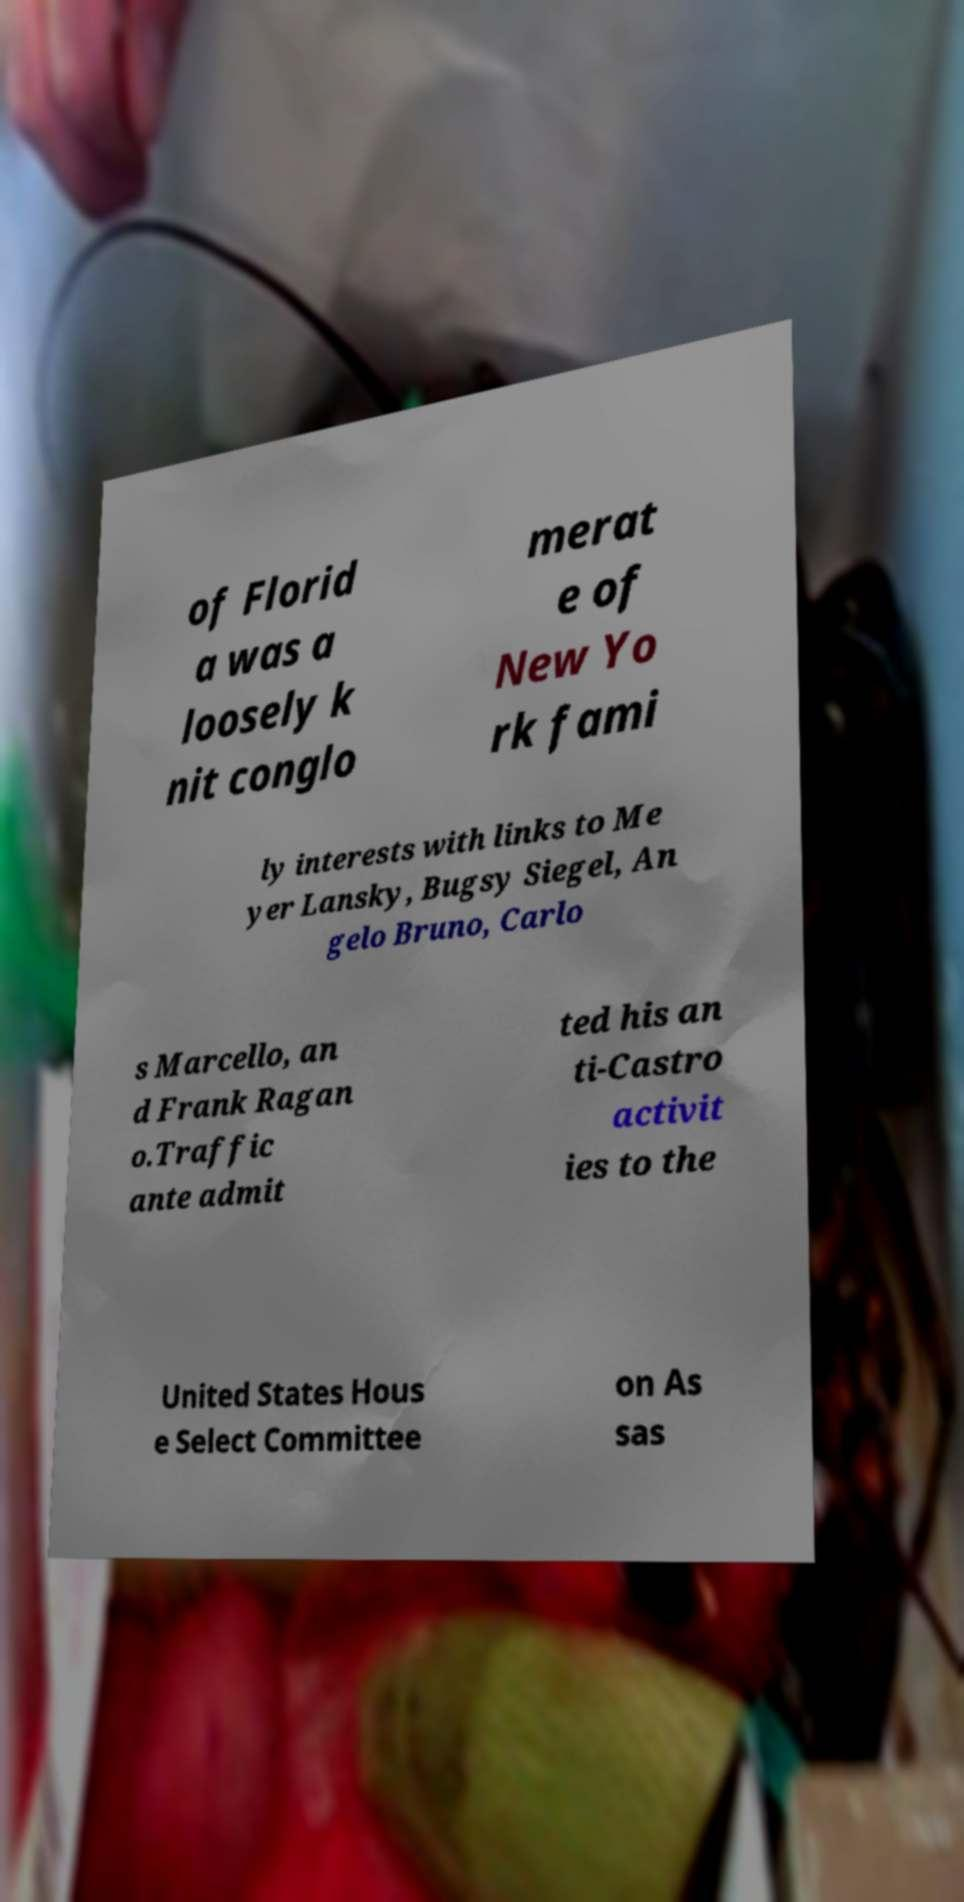Please identify and transcribe the text found in this image. of Florid a was a loosely k nit conglo merat e of New Yo rk fami ly interests with links to Me yer Lansky, Bugsy Siegel, An gelo Bruno, Carlo s Marcello, an d Frank Ragan o.Traffic ante admit ted his an ti-Castro activit ies to the United States Hous e Select Committee on As sas 